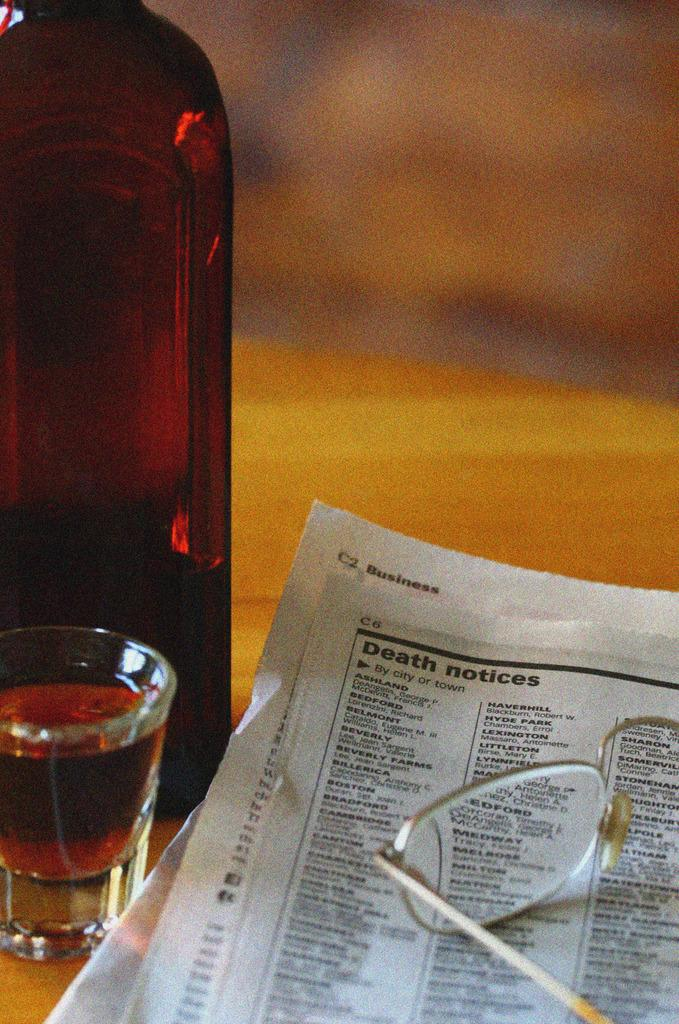<image>
Render a clear and concise summary of the photo. A wooden table with a bottle of brown liquor, eyeglasses, a shot glass and a newspaper opened to the obituary section. 